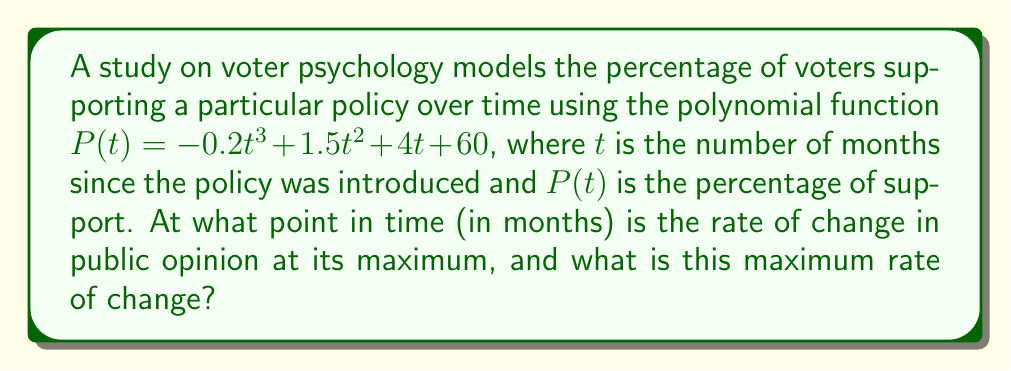Help me with this question. To solve this problem, we need to follow these steps:

1) The rate of change in public opinion is given by the first derivative of $P(t)$. Let's call this $P'(t)$.

   $P'(t) = -0.6t^2 + 3t + 4$

2) To find when the rate of change is at its maximum, we need to find the maximum of $P'(t)$. This occurs when the derivative of $P'(t)$ equals zero. Let's call this second derivative $P''(t)$.

   $P''(t) = -1.2t + 3$

3) Set $P''(t) = 0$ and solve for $t$:

   $-1.2t + 3 = 0$
   $-1.2t = -3$
   $t = 2.5$

4) To confirm this is a maximum (not a minimum), we can check that $P'''(t) < 0$:

   $P'''(t) = -1.2$, which is indeed negative.

5) Now that we know the maximum rate of change occurs at $t = 2.5$ months, we can calculate this maximum rate by plugging $t = 2.5$ into $P'(t)$:

   $P'(2.5) = -0.6(2.5)^2 + 3(2.5) + 4$
            $= -0.6(6.25) + 7.5 + 4$
            $= -3.75 + 11.5$
            $= 7.75$

Therefore, the maximum rate of change occurs 2.5 months after the policy was introduced, and the maximum rate of change is 7.75 percentage points per month.
Answer: 2.5 months; 7.75 percentage points per month 